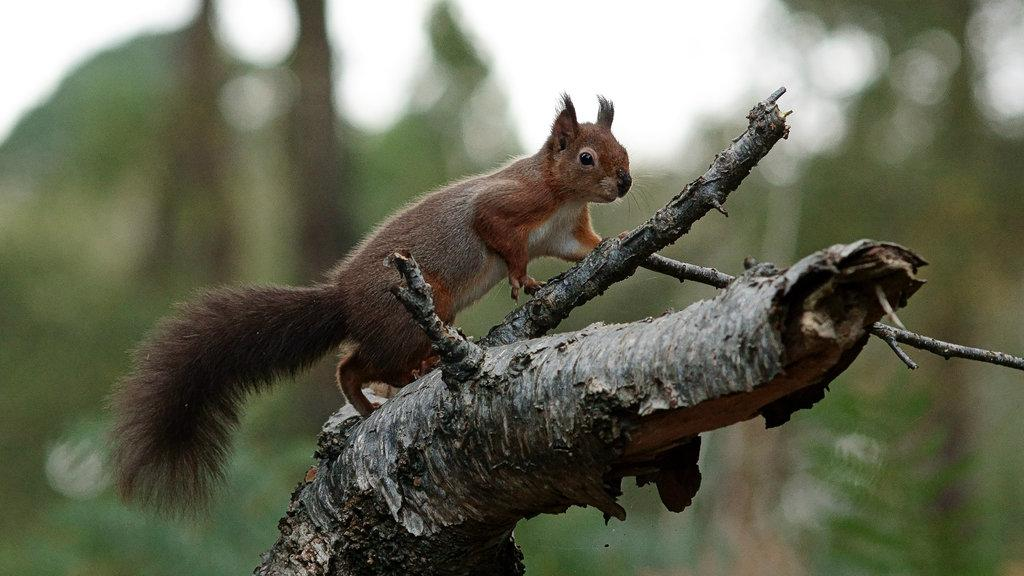What animal is present in the image? There is a squirrel in the image. Where is the squirrel located? The squirrel is on a tree branch. Can you describe the background of the image? The background of the image appears blurry. What word is being spoken by the squirrel in the image? There is no indication that the squirrel is speaking in the image, and therefore no word can be heard. 